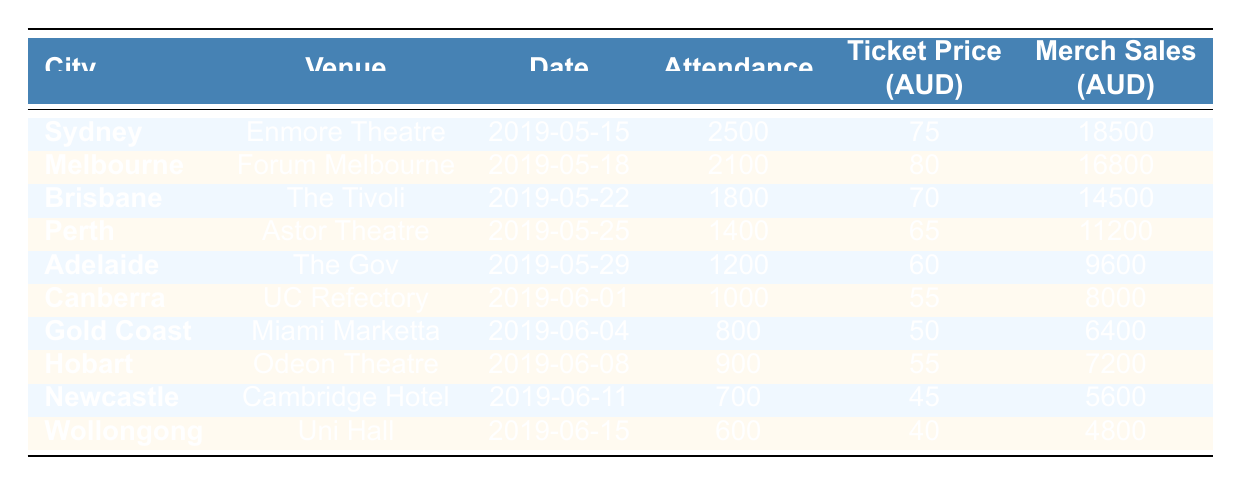What city had the highest concert attendance? Looking at the "Attendance" column, Sydney stands out with an attendance of 2500, which is greater than the figures for all other cities listed.
Answer: Sydney What was the ticket price in Melbourne? Referring to the "Ticket Price (AUD)" column for Melbourne specifically, it shows that the ticket price was 80 AUD.
Answer: 80 AUD How many more attendees were in Sydney than in Wollongong? Sydney had an attendance of 2500 while Wollongong had 600. Subtracting these gives 2500 - 600 = 1900, indicating Sydney had 1900 more attendees.
Answer: 1900 What was the total attendance across all cities? To find the total attendance, we sum all the attendance figures: 2500 + 2100 + 1800 + 1400 + 1200 + 1000 + 800 + 900 + 700 + 600 = 13500.
Answer: 13500 How much merchandise was sold in Brisbane compared to Canberra? Brisbane's merchandise sales were 14500 AUD, and Canberra's were 8000 AUD. The difference is 14500 - 8000 = 6500 AUD, meaning Brisbane sold 6500 AUD more in merchandise.
Answer: 6500 AUD Was the average ticket price across all cities higher than 70 AUD? The ticket prices are 75, 80, 70, 65, 60, 55, 50, 55, 45, and 40. Their sum is 75 + 80 + 70 + 65 + 60 + 55 + 50 + 55 + 45 + 40 = 695. Dividing by the total number of cities (10), the average ticket price is 695/10 = 69.5, which is less than 70 AUD.
Answer: No What city had the lowest merchandise sales? By inspecting the "Merch Sales (AUD)" column, Wollongong shows the least sales at 4800 AUD, which is lower than all others.
Answer: Wollongong What is the ratio of attendance between Sydney and Gold Coast? Sydney had 2500 attendees while Gold Coast had 800. The ratio is calculated as 2500:800, which simplifies to 25:8.
Answer: 25:8 Did Adelaide have more attendees than Newcastle? Adelaide's attendance was 1200, while Newcastle's was 700. Since 1200 is greater than 700, it confirms that Adelaide did indeed have more attendees.
Answer: Yes How much total merchandise was sold across all concerts? To find the total merchandise sales, we sum all sales: 18500 + 16800 + 14500 + 11200 + 9600 + 8000 + 6400 + 7200 + 5600 + 4800 = 85600 AUD.
Answer: 85600 AUD 